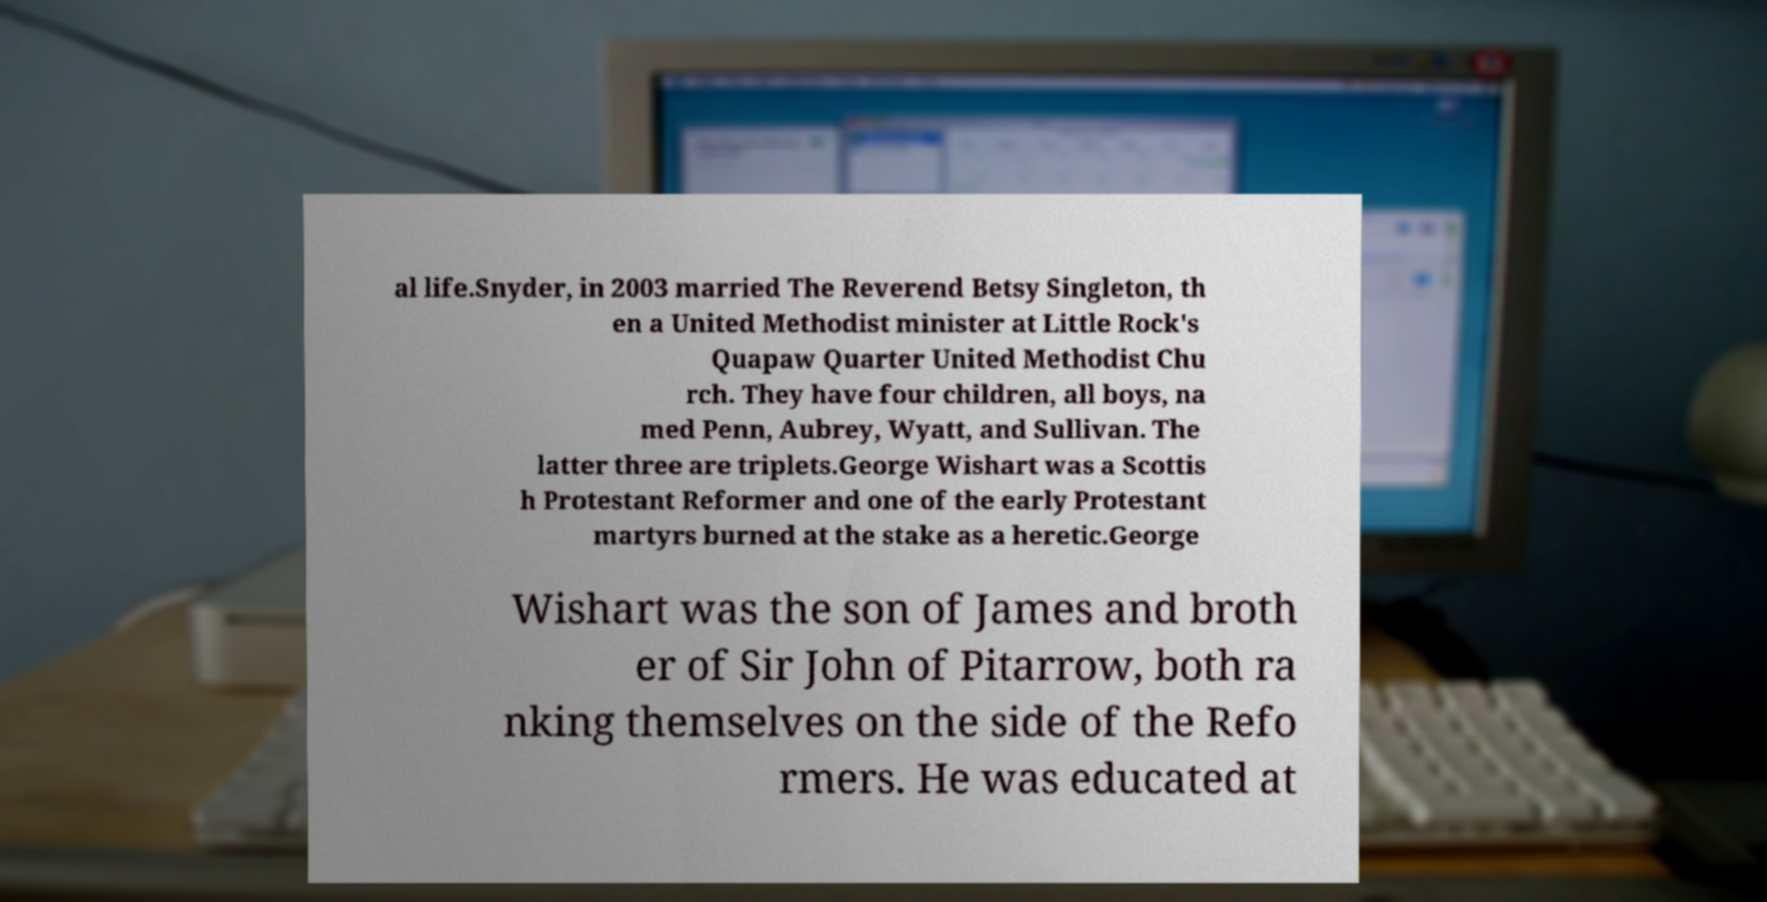Please read and relay the text visible in this image. What does it say? al life.Snyder, in 2003 married The Reverend Betsy Singleton, th en a United Methodist minister at Little Rock's Quapaw Quarter United Methodist Chu rch. They have four children, all boys, na med Penn, Aubrey, Wyatt, and Sullivan. The latter three are triplets.George Wishart was a Scottis h Protestant Reformer and one of the early Protestant martyrs burned at the stake as a heretic.George Wishart was the son of James and broth er of Sir John of Pitarrow, both ra nking themselves on the side of the Refo rmers. He was educated at 